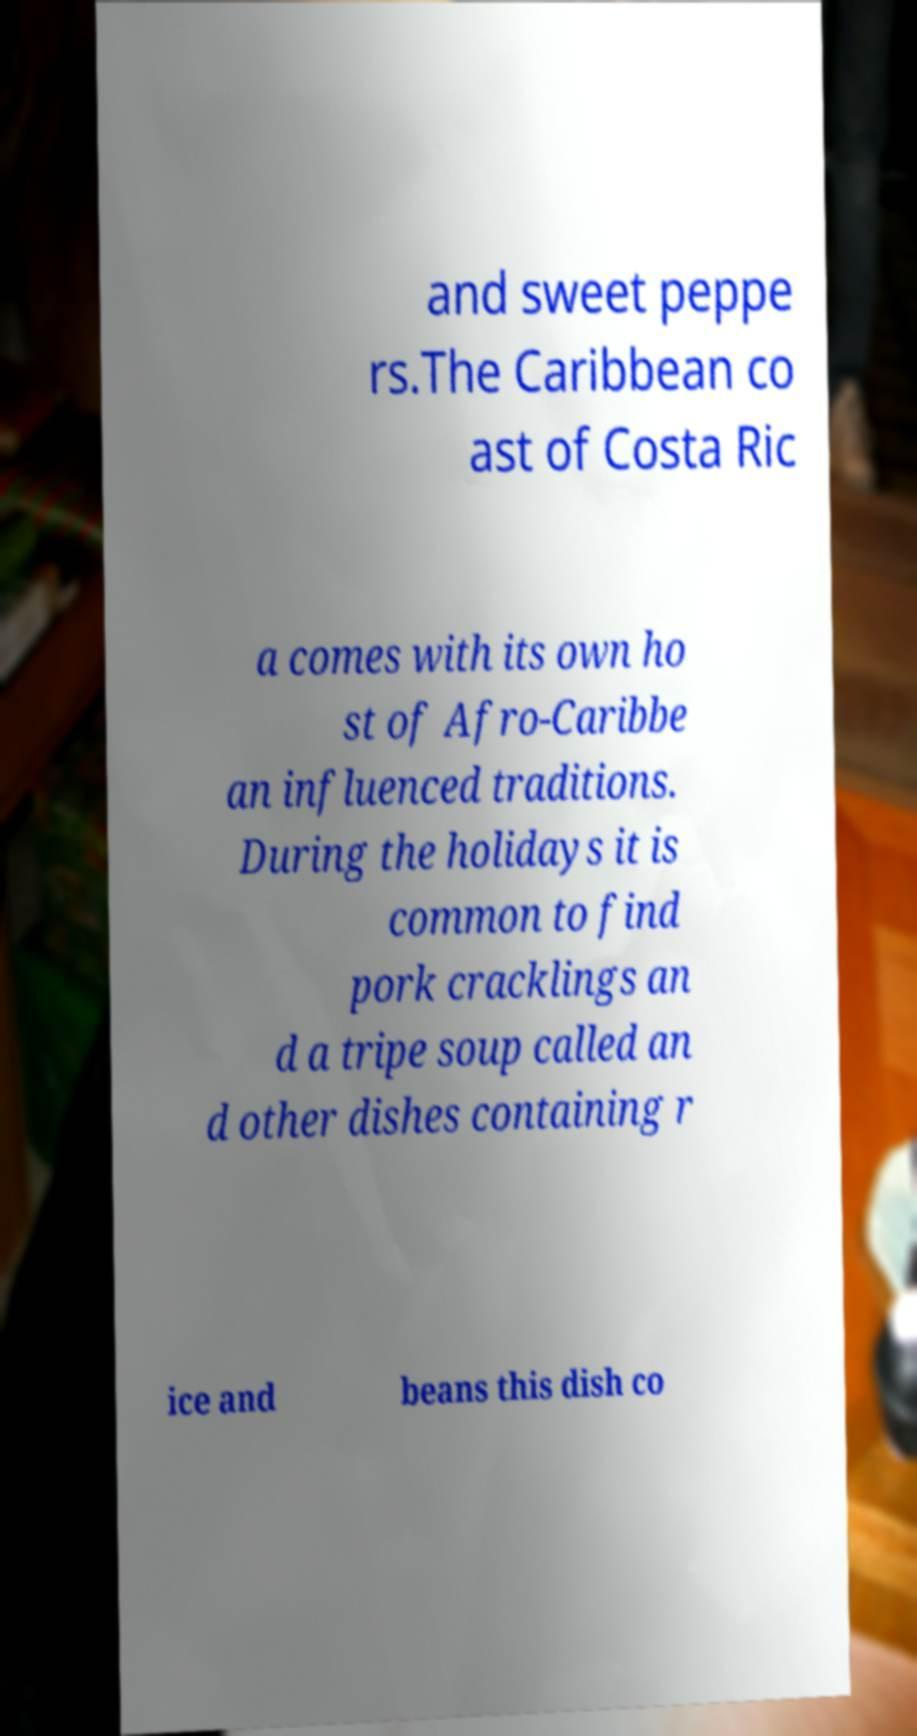Could you assist in decoding the text presented in this image and type it out clearly? and sweet peppe rs.The Caribbean co ast of Costa Ric a comes with its own ho st of Afro-Caribbe an influenced traditions. During the holidays it is common to find pork cracklings an d a tripe soup called an d other dishes containing r ice and beans this dish co 